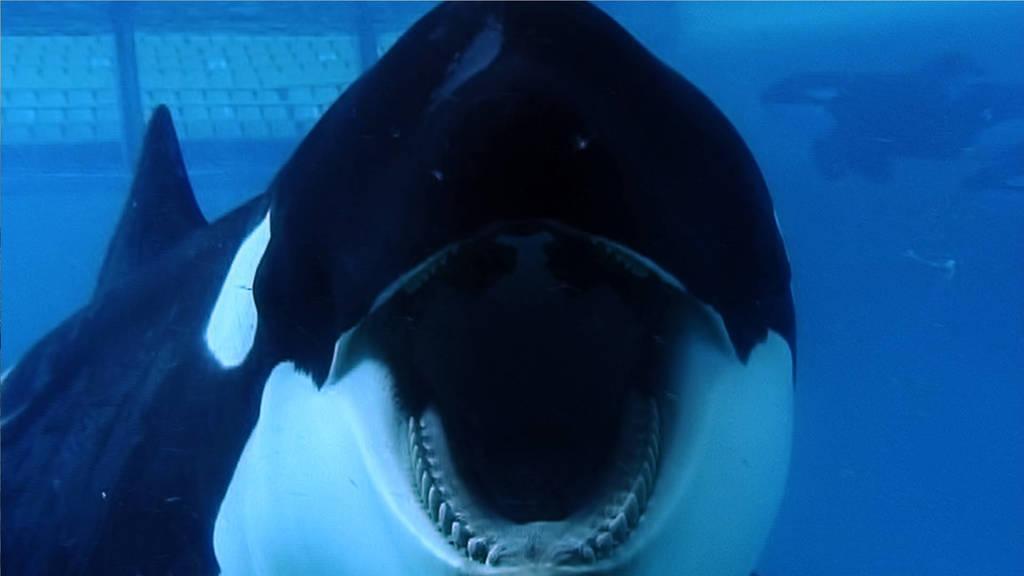In one or two sentences, can you explain what this image depicts? In this picture we can see the close view of the shark fish, under the water. 